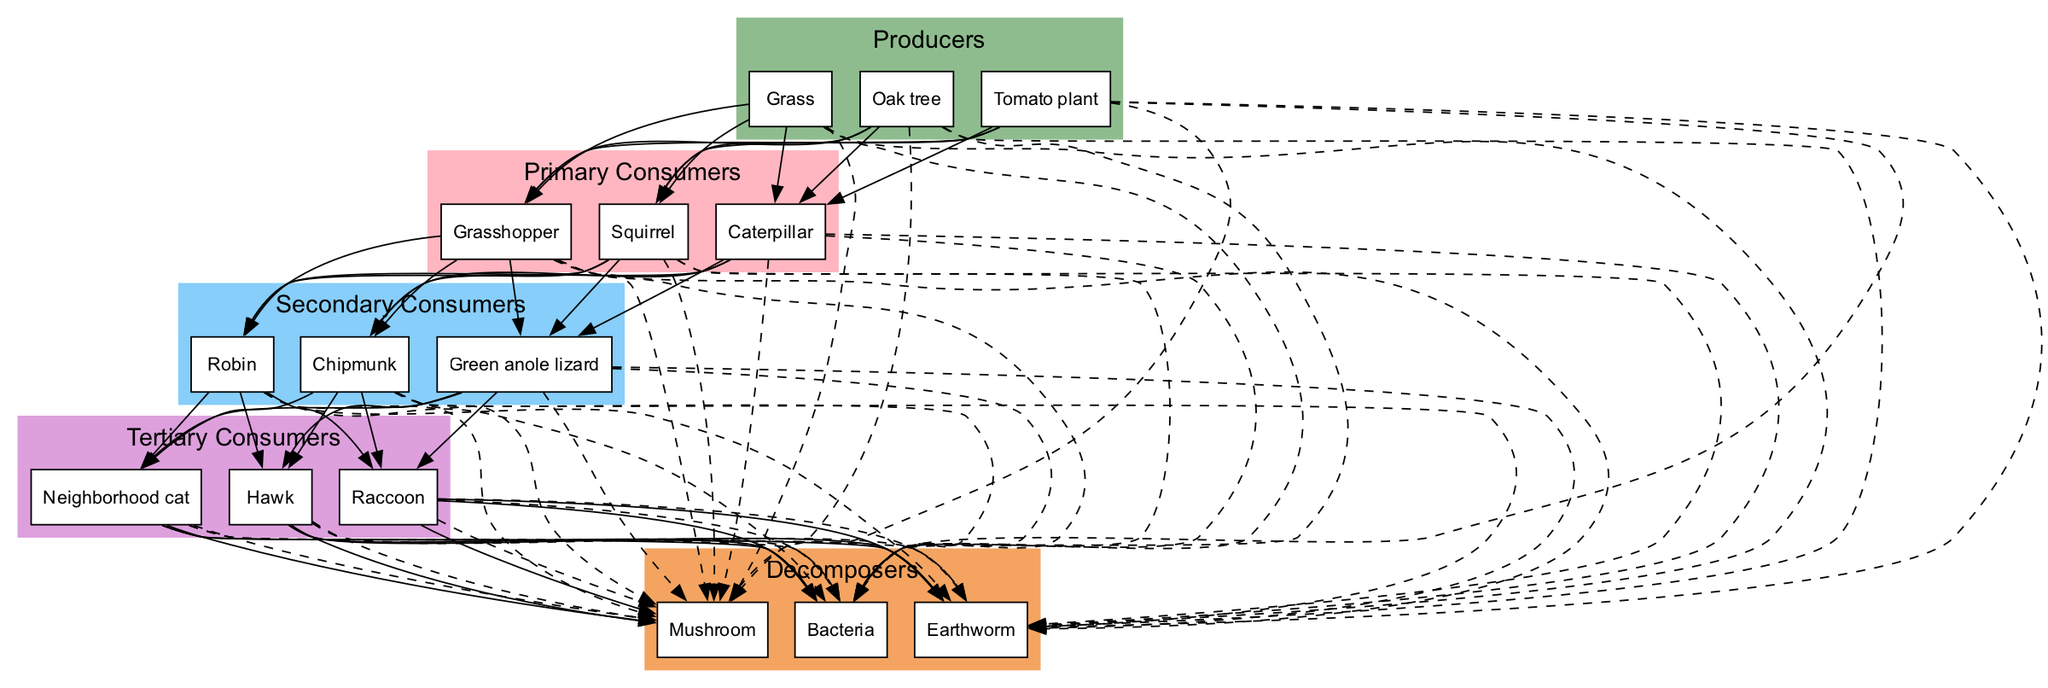What are the producers in this food chain? The diagram lists three organisms as producers. These are the base of the food chain, which use sunlight to create energy. The producers identified are Grass, Oak tree, and Tomato plant.
Answer: Grass, Oak tree, Tomato plant How many primary consumers are in the food chain? The number of primary consumers can be determined by counting the organisms listed in that category in the diagram. There are three primary consumers: Grasshopper, Squirrel, and Caterpillar.
Answer: 3 Which organism is a tertiary consumer in this food chain? The tertiary consumers are the top predators in the food chain. The diagram indicates three organisms in this category: Hawk, Raccoon, and Neighborhood cat. Any of these could be an answer. I will choose Hawk as an example.
Answer: Hawk What relationship exists between the Oak tree and the Robin? To determine this relationship, we can track the connections outlined in the diagram. The Oak tree is a producer, which provides energy to the primary consumers. The Robin, being a secondary consumer, feeds on primary consumers like the Grasshopper, which in turn feeds on the Oak tree. This establishes an indirect connection.
Answer: Indirect How many organisms are decomposers in this ecosystem? To find out the number of decomposers, we look for the organisms categorized under that group in the diagram. There are three decomposers: Earthworm, Mushroom, and Bacteria.
Answer: 3 Which primary consumer feeds on the Grass? We need to check the flow from the producers to primary consumers in the diagram. The Grasshopper is listed as a primary consumer that feeds specifically on Grass.
Answer: Grasshopper Which two groups interact directly in this food chain? To find two groups that interact directly, we look at the arrows in the diagram. The relationship shown indicates that primary consumers directly interact with secondary consumers. For example, Grasshopper (primary) to Robin (secondary) illustrates a direct feeding relationship.
Answer: Primary consumers and secondary consumers Identify one secondary consumer in the food chain. By scanning the secondary consumer category in the diagram, we can identify various organisms. In this case, I will choose Chipmunk as an example of a secondary consumer within the ecosystem.
Answer: Chipmunk 